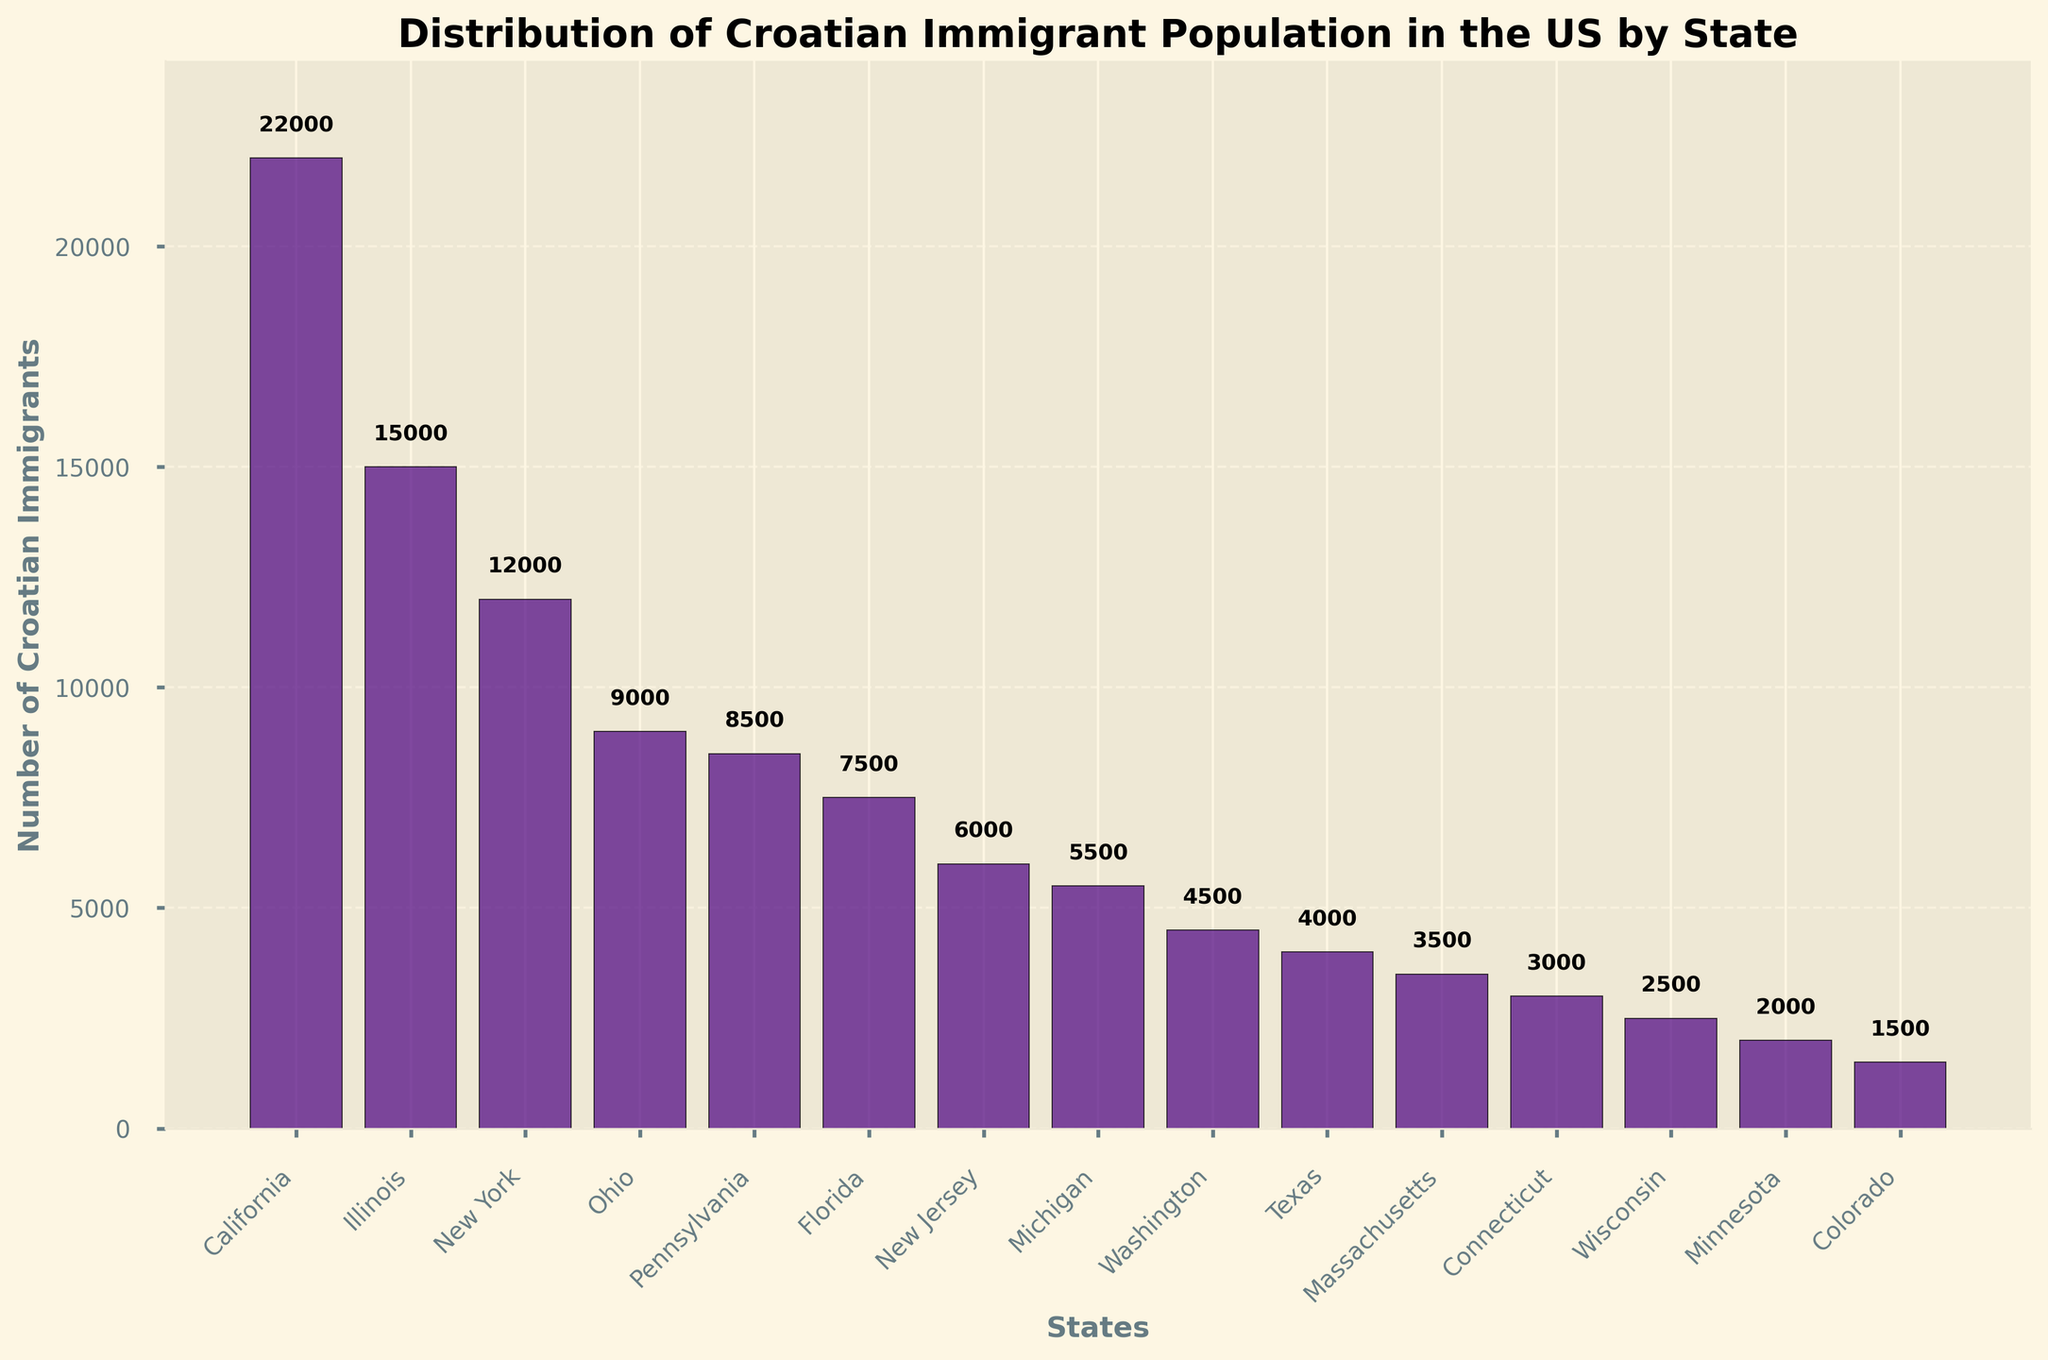Which state has the highest number of Croatian immigrants? Looking at the height of the bars, California has the tallest bar representing the highest number of Croatian immigrants.
Answer: California What is the title of the figure? The title is displayed at the top of the figure in a larger and bold font.
Answer: Distribution of Croatian Immigrant Population in the US by State How many Croatian immigrants are in Texas according to the figure? The bar representing Texas has the value written right above it.
Answer: 4,000 Which two states have the smallest Croatian immigrant population, and what are those numbers? Observing the shortest bars in the figure, the two states are Minnesota and Colorado with 2,000 and 1,500 immigrants respectively.
Answer: Minnesota (2,000) and Colorado (1,500) What is the combined total of Croatian immigrants in Ohio and Pennsylvania? The bars representing Ohio and Pennsylvania show 9,000 and 8,500 immigrants respectively. Adding these values gives 9,000 + 8,500.
Answer: 17,500 How does the number of Croatian immigrants in New York compare to that in Florida? Comparing the heights of the bars, New York has 12,000 immigrants while Florida has 7,500.
Answer: New York has more Which state has approximately half the number of Croatian immigrants as California? Identifying the state with a bar height near half of California's 22,000, we see Illinois with 15,000. 15,000 is close to half of 22,000.
Answer: Illinois (15,000) What is the difference in the number of Croatian immigrants between Illinois and New Jersey? The bar for Illinois shows 15,000 immigrants, and New Jersey shows 6,000. Subtracting these gives 15,000 - 6,000.
Answer: 9,000 How many states have a Croatian immigrant population greater than 10,000? Counting the bars that exceed the 10,000 mark, we see there are three such states: California, Illinois, and New York.
Answer: 3 How many Croatian immigrants are there in total across all listed states? Summing up all the numbers presented above the bars: 22,000 + 15,000 + 12,000 + 9,000 + 8,500 + 7,500 + 6,000 + 5,500 + 4,500 + 4,000 + 3,500 + 3,000 + 2,500 + 2,000 + 1,500 = 106,000.
Answer: 106,000 